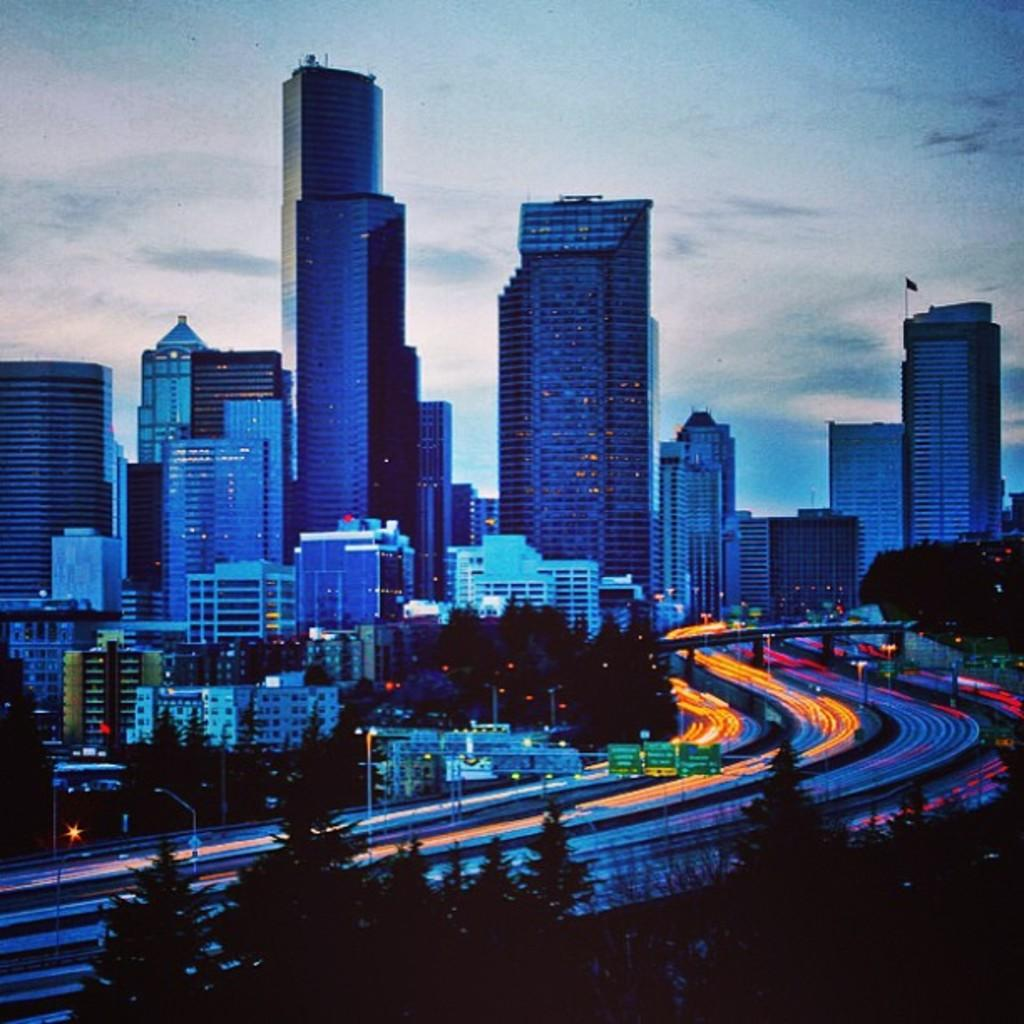What type of vegetation is present in the image? There are many trees in the image. What type of structures can be seen in the image? There are many buildings and skyscrapers in the image. How many bridges are visible in the image? There are few bridges in the image. What type of lighting is present in the image? There are many street lights in the image. What part of the natural environment is visible in the image? The sky is visible in the image. What color is the chalk used to draw on the support in the image? There is no chalk or support present in the image. How does the competition affect the buildings in the image? There is no competition mentioned in the image, so it cannot affect the buildings. 